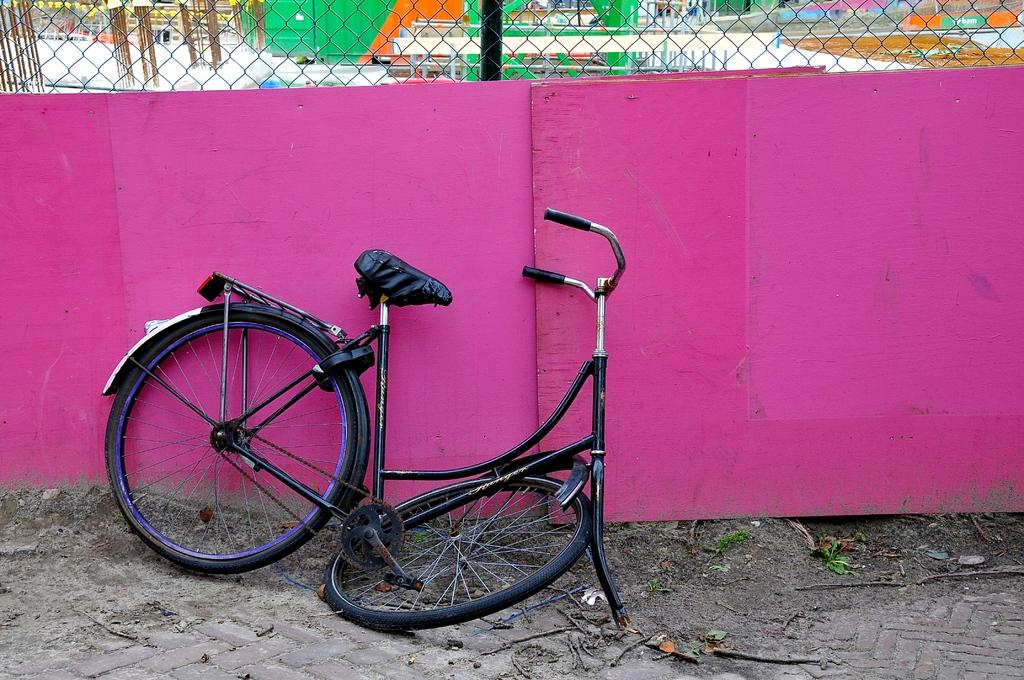What is the main subject in the center of the image? There is a cycle in the center of the image. What is located at the bottom of the image? There is a walkway at the bottom of the image, along with sand and scrap. What can be seen in the background of the image? There is a net, boards, benches, and other objects in the background of the image. What type of door can be seen in the image? There is no door present in the image. How much force is being applied to the pickle in the image? There is no pickle present in the image, so it is not possible to determine the force being applied. 